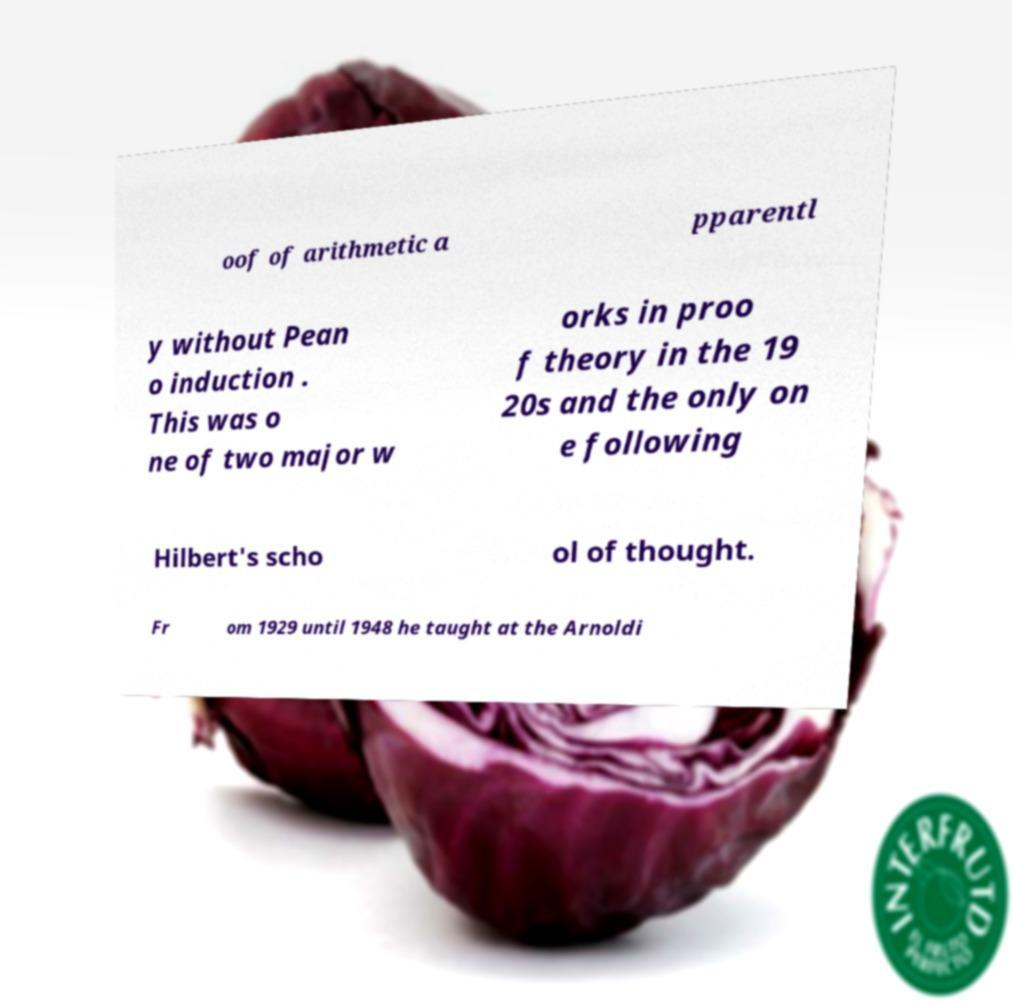Please identify and transcribe the text found in this image. oof of arithmetic a pparentl y without Pean o induction . This was o ne of two major w orks in proo f theory in the 19 20s and the only on e following Hilbert's scho ol of thought. Fr om 1929 until 1948 he taught at the Arnoldi 